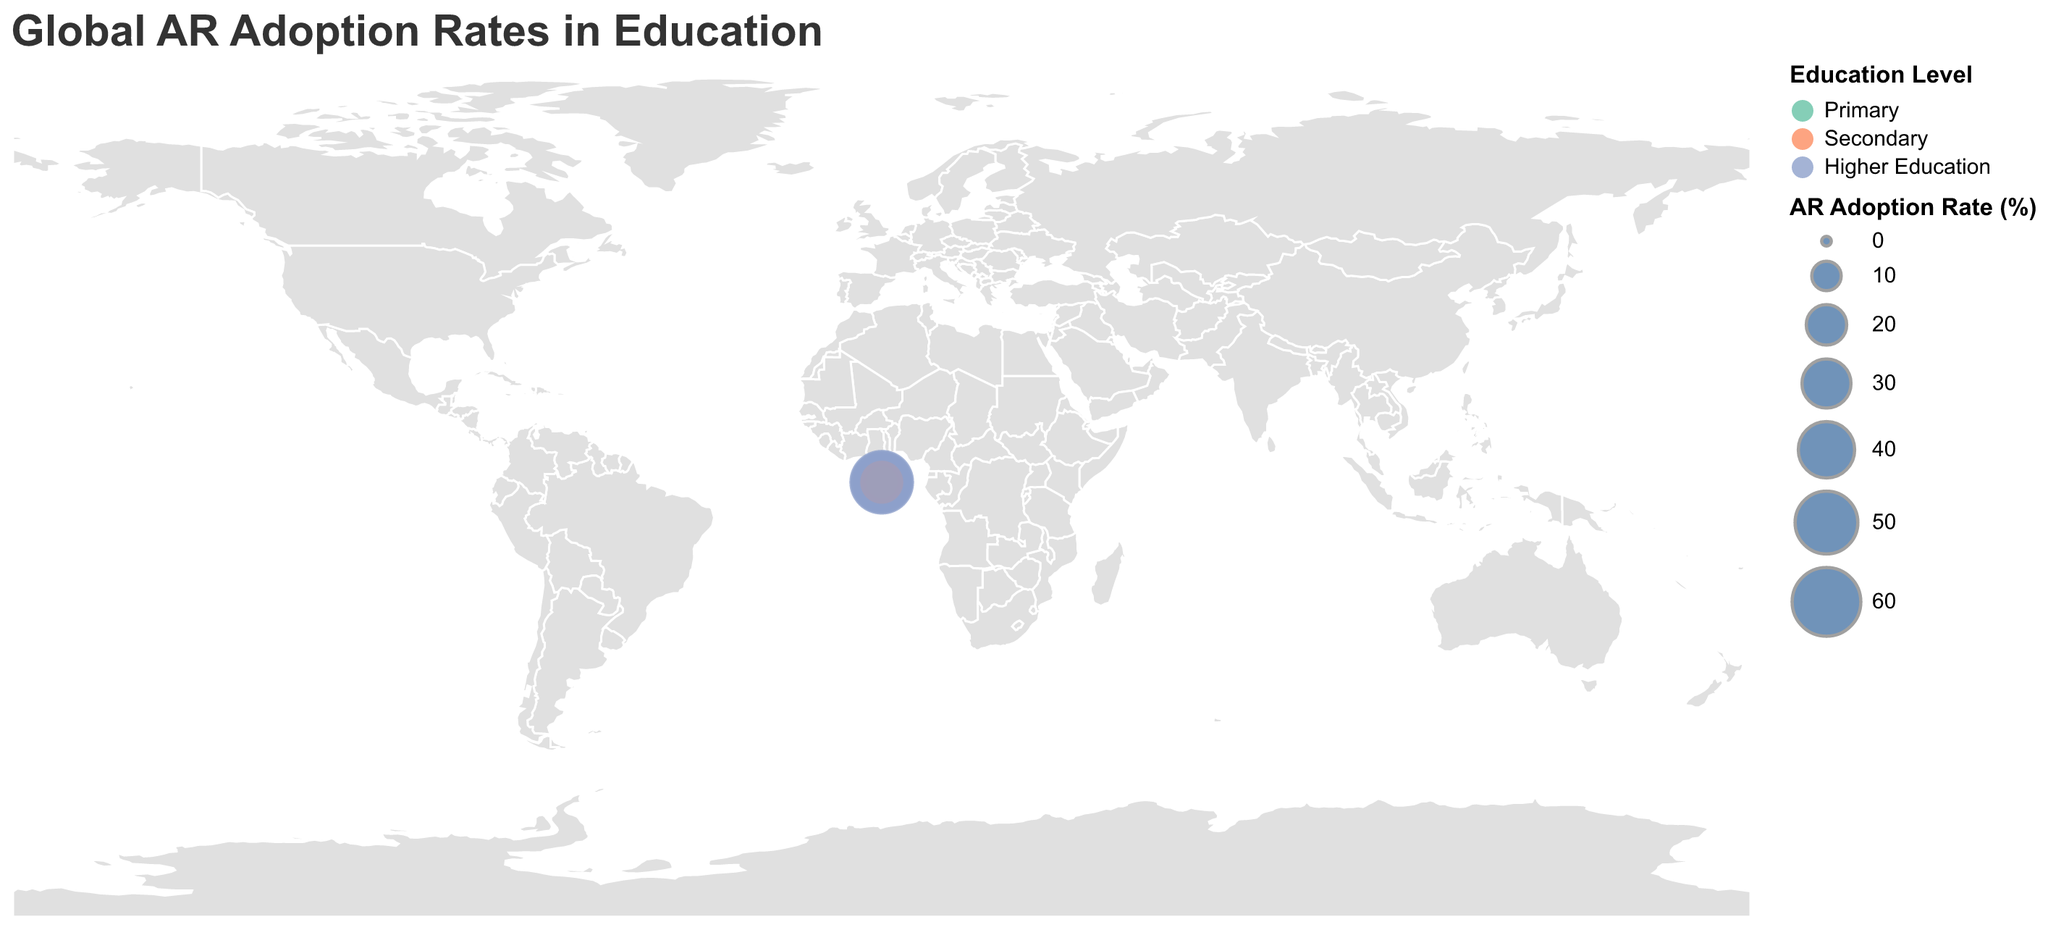What's the title of the figure? The title is located at the top of the figure.
Answer: Global AR Adoption Rates in Education How many countries are represented in the figure? Count the number of unique countries listed in the data.
Answer: 10 Which country has the highest AR adoption rate in primary education? Look for the highest percentage in the Primary education level column for each country.
Answer: South Korea What's the difference in AR adoption rates in higher education between Japan and India? Subtract the AR adoption rate for India from that for Japan in higher education. 47.8 - 29.1 = 18.7
Answer: 18.7 Which education level has the highest AR adoption rate in South Korea? Compare the AR adoption rates across different education levels for South Korea.
Answer: Higher Education In which education level does Germany have the lowest AR adoption rate? Check the data for Germany and find the lowest percentage among the Primary, Secondary, and Higher Education levels.
Answer: Primary What's the combined AR adoption rate for all education levels in the United Kingdom? Sum the AR adoption rates for primary, secondary, and higher education in the United Kingdom. 14.8 + 27.3 + 41.5 = 83.6
Answer: 83.6 How does France's AR adoption rate in primary education compare to Australia's? Check the AR adoption rates for primary education in France and Australia and compare them.
Answer: France: 11.6, Australia: 13.5 Which countries have a higher AR adoption rate in secondary education than the United States? Compare each country's AR adoption rate in secondary education to that of the United States (28.7%).
Answer: Japan, South Korea, China What's the average AR adoption rate in higher education across all countries? Sum the AR adoption rates for higher education in all countries and divide by the number of countries. (42.3 + 47.8 + 38.6 + 53.2 + 41.5 + 49.6 + 39.4 + 40.8 + 29.1 + 36.2)/10 = 41.85
Answer: 41.85 